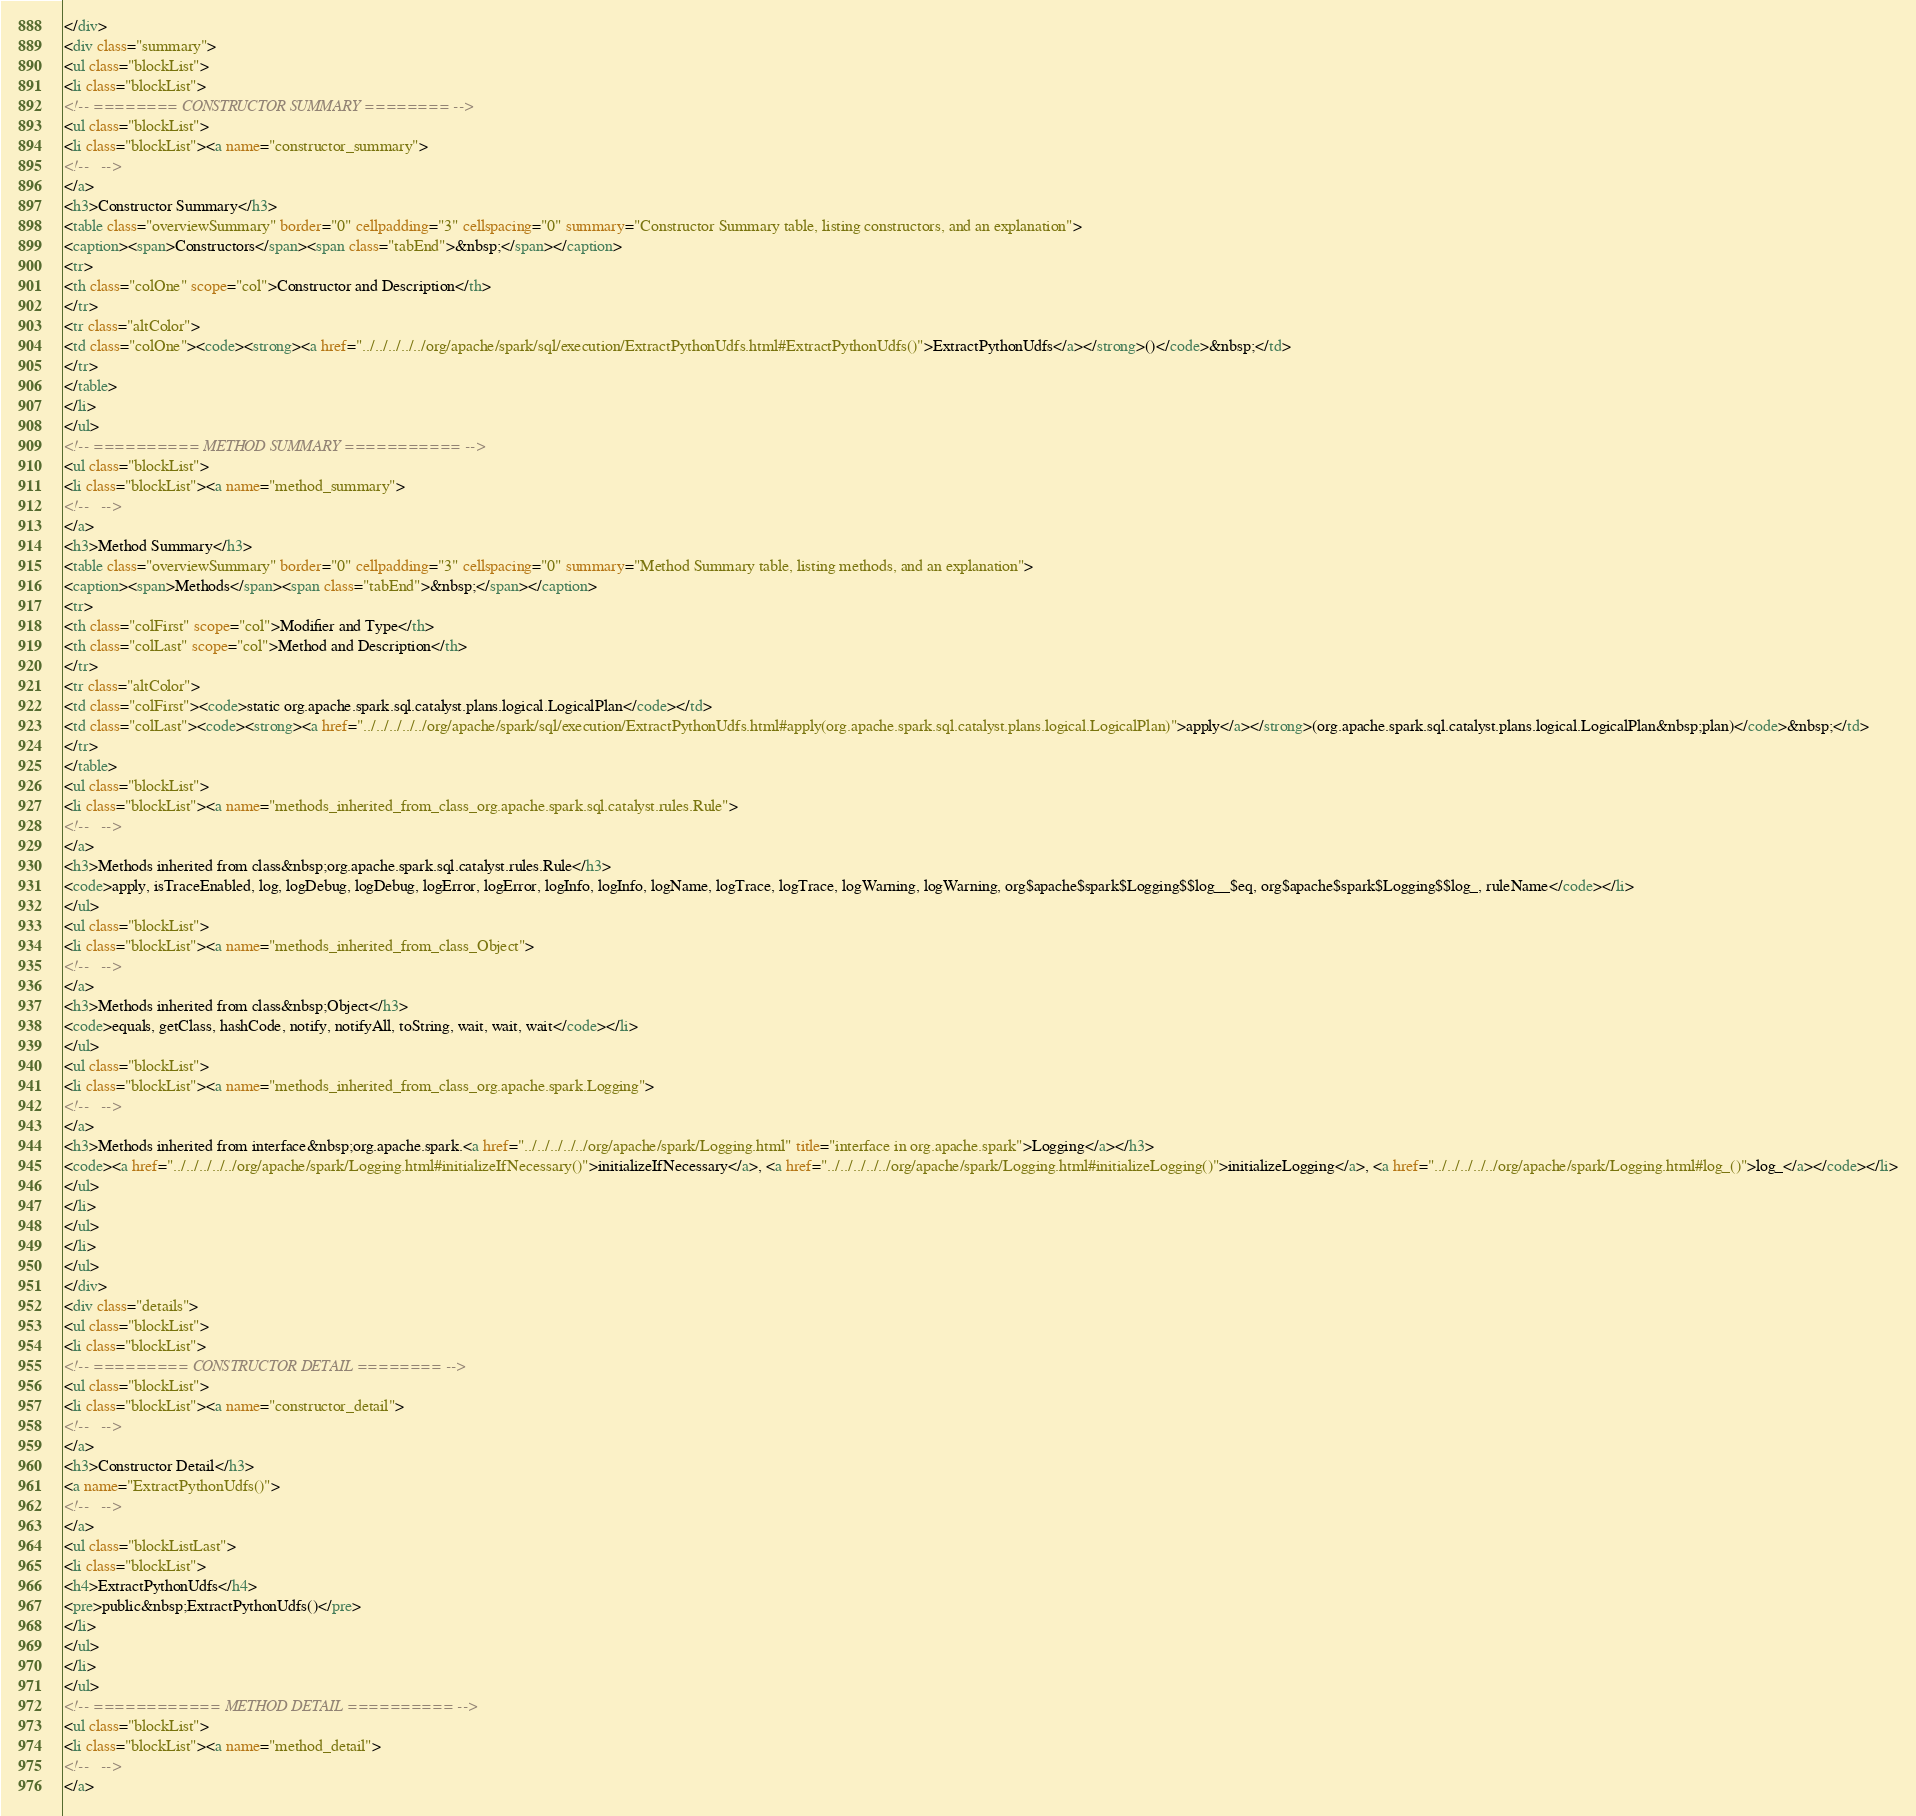<code> <loc_0><loc_0><loc_500><loc_500><_HTML_></div>
<div class="summary">
<ul class="blockList">
<li class="blockList">
<!-- ======== CONSTRUCTOR SUMMARY ======== -->
<ul class="blockList">
<li class="blockList"><a name="constructor_summary">
<!--   -->
</a>
<h3>Constructor Summary</h3>
<table class="overviewSummary" border="0" cellpadding="3" cellspacing="0" summary="Constructor Summary table, listing constructors, and an explanation">
<caption><span>Constructors</span><span class="tabEnd">&nbsp;</span></caption>
<tr>
<th class="colOne" scope="col">Constructor and Description</th>
</tr>
<tr class="altColor">
<td class="colOne"><code><strong><a href="../../../../../org/apache/spark/sql/execution/ExtractPythonUdfs.html#ExtractPythonUdfs()">ExtractPythonUdfs</a></strong>()</code>&nbsp;</td>
</tr>
</table>
</li>
</ul>
<!-- ========== METHOD SUMMARY =========== -->
<ul class="blockList">
<li class="blockList"><a name="method_summary">
<!--   -->
</a>
<h3>Method Summary</h3>
<table class="overviewSummary" border="0" cellpadding="3" cellspacing="0" summary="Method Summary table, listing methods, and an explanation">
<caption><span>Methods</span><span class="tabEnd">&nbsp;</span></caption>
<tr>
<th class="colFirst" scope="col">Modifier and Type</th>
<th class="colLast" scope="col">Method and Description</th>
</tr>
<tr class="altColor">
<td class="colFirst"><code>static org.apache.spark.sql.catalyst.plans.logical.LogicalPlan</code></td>
<td class="colLast"><code><strong><a href="../../../../../org/apache/spark/sql/execution/ExtractPythonUdfs.html#apply(org.apache.spark.sql.catalyst.plans.logical.LogicalPlan)">apply</a></strong>(org.apache.spark.sql.catalyst.plans.logical.LogicalPlan&nbsp;plan)</code>&nbsp;</td>
</tr>
</table>
<ul class="blockList">
<li class="blockList"><a name="methods_inherited_from_class_org.apache.spark.sql.catalyst.rules.Rule">
<!--   -->
</a>
<h3>Methods inherited from class&nbsp;org.apache.spark.sql.catalyst.rules.Rule</h3>
<code>apply, isTraceEnabled, log, logDebug, logDebug, logError, logError, logInfo, logInfo, logName, logTrace, logTrace, logWarning, logWarning, org$apache$spark$Logging$$log__$eq, org$apache$spark$Logging$$log_, ruleName</code></li>
</ul>
<ul class="blockList">
<li class="blockList"><a name="methods_inherited_from_class_Object">
<!--   -->
</a>
<h3>Methods inherited from class&nbsp;Object</h3>
<code>equals, getClass, hashCode, notify, notifyAll, toString, wait, wait, wait</code></li>
</ul>
<ul class="blockList">
<li class="blockList"><a name="methods_inherited_from_class_org.apache.spark.Logging">
<!--   -->
</a>
<h3>Methods inherited from interface&nbsp;org.apache.spark.<a href="../../../../../org/apache/spark/Logging.html" title="interface in org.apache.spark">Logging</a></h3>
<code><a href="../../../../../org/apache/spark/Logging.html#initializeIfNecessary()">initializeIfNecessary</a>, <a href="../../../../../org/apache/spark/Logging.html#initializeLogging()">initializeLogging</a>, <a href="../../../../../org/apache/spark/Logging.html#log_()">log_</a></code></li>
</ul>
</li>
</ul>
</li>
</ul>
</div>
<div class="details">
<ul class="blockList">
<li class="blockList">
<!-- ========= CONSTRUCTOR DETAIL ======== -->
<ul class="blockList">
<li class="blockList"><a name="constructor_detail">
<!--   -->
</a>
<h3>Constructor Detail</h3>
<a name="ExtractPythonUdfs()">
<!--   -->
</a>
<ul class="blockListLast">
<li class="blockList">
<h4>ExtractPythonUdfs</h4>
<pre>public&nbsp;ExtractPythonUdfs()</pre>
</li>
</ul>
</li>
</ul>
<!-- ============ METHOD DETAIL ========== -->
<ul class="blockList">
<li class="blockList"><a name="method_detail">
<!--   -->
</a></code> 